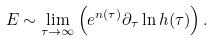Convert formula to latex. <formula><loc_0><loc_0><loc_500><loc_500>E \sim \lim _ { \tau \to \infty } \left ( e ^ { n ( \tau ) } \partial _ { \tau } \ln h ( \tau ) \right ) .</formula> 